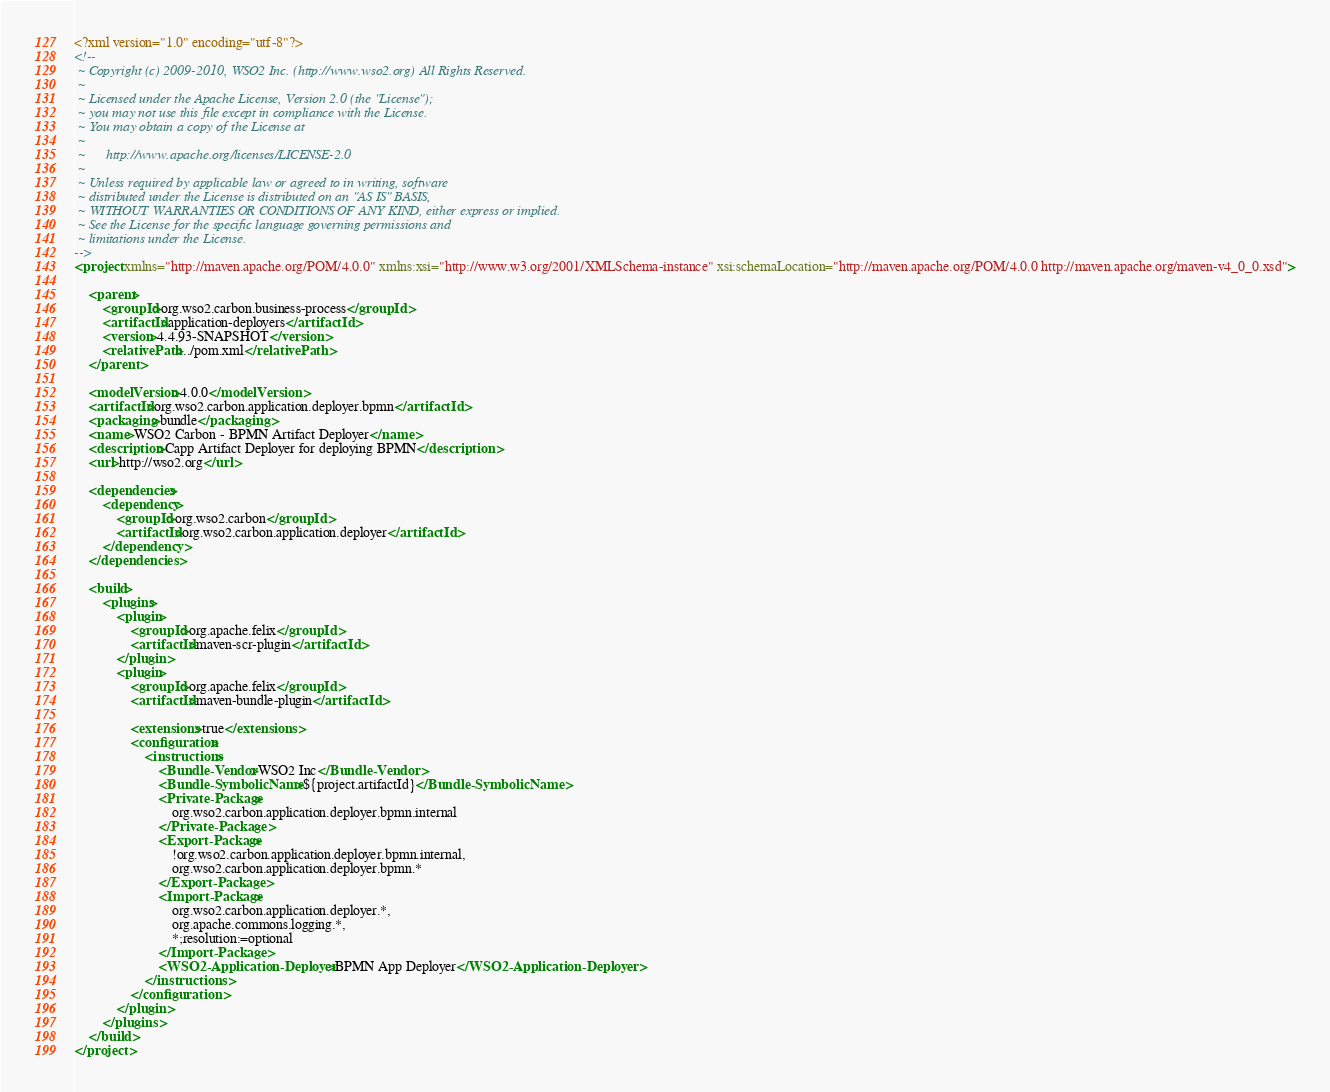Convert code to text. <code><loc_0><loc_0><loc_500><loc_500><_XML_><?xml version="1.0" encoding="utf-8"?>
<!--
 ~ Copyright (c) 2009-2010, WSO2 Inc. (http://www.wso2.org) All Rights Reserved.
 ~
 ~ Licensed under the Apache License, Version 2.0 (the "License");
 ~ you may not use this file except in compliance with the License.
 ~ You may obtain a copy of the License at
 ~
 ~      http://www.apache.org/licenses/LICENSE-2.0
 ~
 ~ Unless required by applicable law or agreed to in writing, software
 ~ distributed under the License is distributed on an "AS IS" BASIS,
 ~ WITHOUT WARRANTIES OR CONDITIONS OF ANY KIND, either express or implied.
 ~ See the License for the specific language governing permissions and
 ~ limitations under the License.
-->
<project xmlns="http://maven.apache.org/POM/4.0.0" xmlns:xsi="http://www.w3.org/2001/XMLSchema-instance" xsi:schemaLocation="http://maven.apache.org/POM/4.0.0 http://maven.apache.org/maven-v4_0_0.xsd">

    <parent>
        <groupId>org.wso2.carbon.business-process</groupId>
        <artifactId>application-deployers</artifactId>
        <version>4.4.93-SNAPSHOT</version>
        <relativePath>../pom.xml</relativePath>
    </parent>

    <modelVersion>4.0.0</modelVersion>
    <artifactId>org.wso2.carbon.application.deployer.bpmn</artifactId>
    <packaging>bundle</packaging>
    <name>WSO2 Carbon - BPMN Artifact Deployer</name>
    <description>Capp Artifact Deployer for deploying BPMN</description>
    <url>http://wso2.org</url>

    <dependencies>
        <dependency>
            <groupId>org.wso2.carbon</groupId>
            <artifactId>org.wso2.carbon.application.deployer</artifactId>
        </dependency>
    </dependencies>

    <build>
        <plugins>
            <plugin>
                <groupId>org.apache.felix</groupId>
                <artifactId>maven-scr-plugin</artifactId>
            </plugin>
            <plugin>
                <groupId>org.apache.felix</groupId>
                <artifactId>maven-bundle-plugin</artifactId>
                
                <extensions>true</extensions>
                <configuration>
                    <instructions>
                        <Bundle-Vendor>WSO2 Inc</Bundle-Vendor>
                        <Bundle-SymbolicName>${project.artifactId}</Bundle-SymbolicName>
                        <Private-Package>
                            org.wso2.carbon.application.deployer.bpmn.internal
                        </Private-Package>
                        <Export-Package>
                            !org.wso2.carbon.application.deployer.bpmn.internal,
                            org.wso2.carbon.application.deployer.bpmn.*
                        </Export-Package>
                        <Import-Package>
                            org.wso2.carbon.application.deployer.*,
                            org.apache.commons.logging.*,
                            *;resolution:=optional
                        </Import-Package>
                        <WSO2-Application-Deployer>BPMN App Deployer</WSO2-Application-Deployer>
                    </instructions>
                </configuration>
            </plugin>
        </plugins>
    </build>
</project>
</code> 